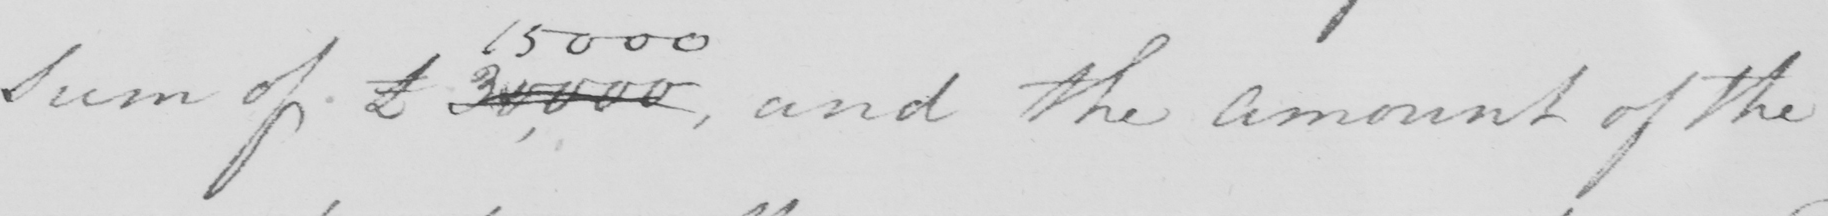What is written in this line of handwriting? Sum of £30,000  , and the Amount of the 